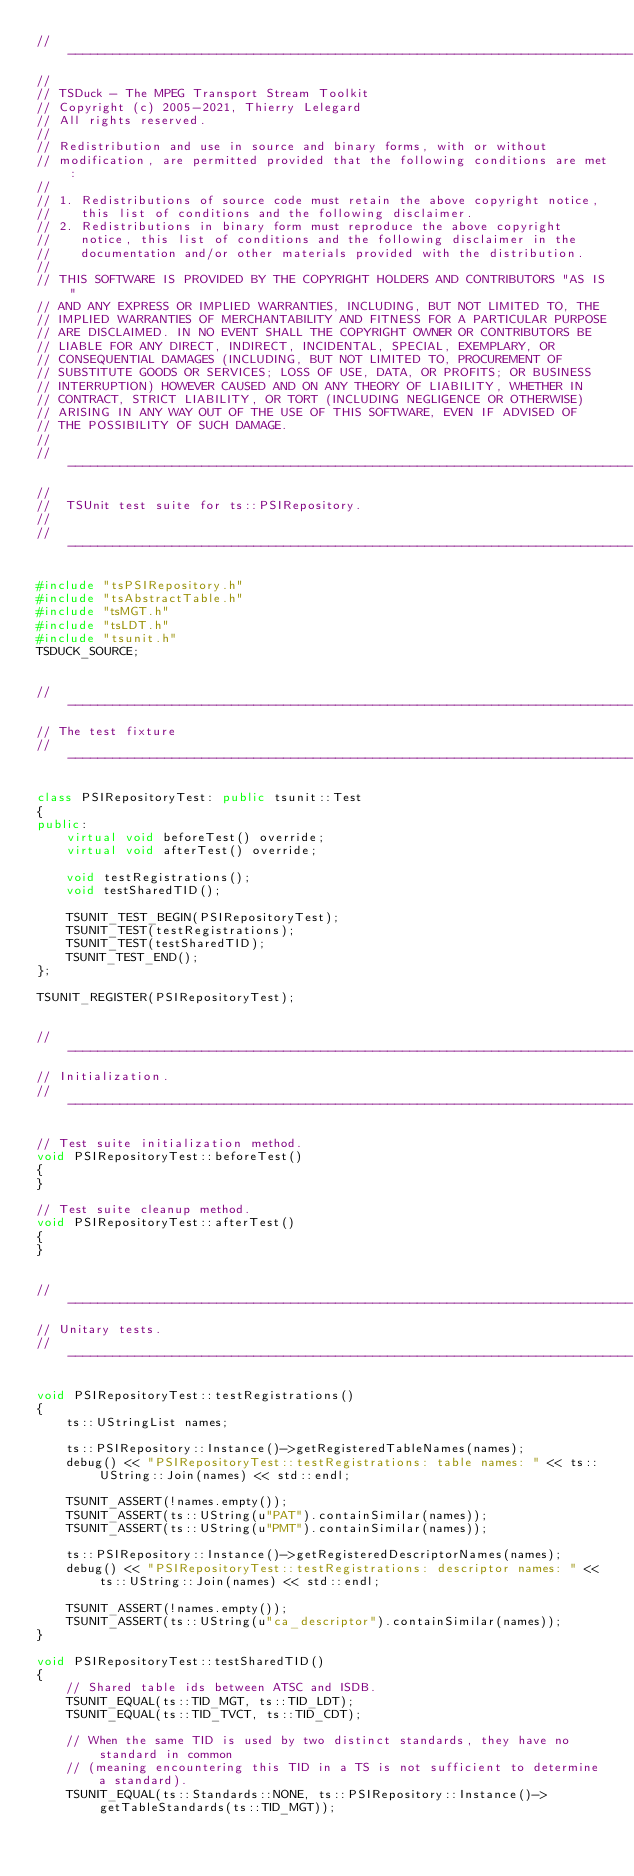<code> <loc_0><loc_0><loc_500><loc_500><_C++_>//----------------------------------------------------------------------------
//
// TSDuck - The MPEG Transport Stream Toolkit
// Copyright (c) 2005-2021, Thierry Lelegard
// All rights reserved.
//
// Redistribution and use in source and binary forms, with or without
// modification, are permitted provided that the following conditions are met:
//
// 1. Redistributions of source code must retain the above copyright notice,
//    this list of conditions and the following disclaimer.
// 2. Redistributions in binary form must reproduce the above copyright
//    notice, this list of conditions and the following disclaimer in the
//    documentation and/or other materials provided with the distribution.
//
// THIS SOFTWARE IS PROVIDED BY THE COPYRIGHT HOLDERS AND CONTRIBUTORS "AS IS"
// AND ANY EXPRESS OR IMPLIED WARRANTIES, INCLUDING, BUT NOT LIMITED TO, THE
// IMPLIED WARRANTIES OF MERCHANTABILITY AND FITNESS FOR A PARTICULAR PURPOSE
// ARE DISCLAIMED. IN NO EVENT SHALL THE COPYRIGHT OWNER OR CONTRIBUTORS BE
// LIABLE FOR ANY DIRECT, INDIRECT, INCIDENTAL, SPECIAL, EXEMPLARY, OR
// CONSEQUENTIAL DAMAGES (INCLUDING, BUT NOT LIMITED TO, PROCUREMENT OF
// SUBSTITUTE GOODS OR SERVICES; LOSS OF USE, DATA, OR PROFITS; OR BUSINESS
// INTERRUPTION) HOWEVER CAUSED AND ON ANY THEORY OF LIABILITY, WHETHER IN
// CONTRACT, STRICT LIABILITY, OR TORT (INCLUDING NEGLIGENCE OR OTHERWISE)
// ARISING IN ANY WAY OUT OF THE USE OF THIS SOFTWARE, EVEN IF ADVISED OF
// THE POSSIBILITY OF SUCH DAMAGE.
//
//----------------------------------------------------------------------------
//
//  TSUnit test suite for ts::PSIRepository.
//
//----------------------------------------------------------------------------

#include "tsPSIRepository.h"
#include "tsAbstractTable.h"
#include "tsMGT.h"
#include "tsLDT.h"
#include "tsunit.h"
TSDUCK_SOURCE;


//----------------------------------------------------------------------------
// The test fixture
//----------------------------------------------------------------------------

class PSIRepositoryTest: public tsunit::Test
{
public:
    virtual void beforeTest() override;
    virtual void afterTest() override;

    void testRegistrations();
    void testSharedTID();

    TSUNIT_TEST_BEGIN(PSIRepositoryTest);
    TSUNIT_TEST(testRegistrations);
    TSUNIT_TEST(testSharedTID);
    TSUNIT_TEST_END();
};

TSUNIT_REGISTER(PSIRepositoryTest);


//----------------------------------------------------------------------------
// Initialization.
//----------------------------------------------------------------------------

// Test suite initialization method.
void PSIRepositoryTest::beforeTest()
{
}

// Test suite cleanup method.
void PSIRepositoryTest::afterTest()
{
}


//----------------------------------------------------------------------------
// Unitary tests.
//----------------------------------------------------------------------------

void PSIRepositoryTest::testRegistrations()
{
    ts::UStringList names;

    ts::PSIRepository::Instance()->getRegisteredTableNames(names);
    debug() << "PSIRepositoryTest::testRegistrations: table names: " << ts::UString::Join(names) << std::endl;

    TSUNIT_ASSERT(!names.empty());
    TSUNIT_ASSERT(ts::UString(u"PAT").containSimilar(names));
    TSUNIT_ASSERT(ts::UString(u"PMT").containSimilar(names));

    ts::PSIRepository::Instance()->getRegisteredDescriptorNames(names);
    debug() << "PSIRepositoryTest::testRegistrations: descriptor names: " << ts::UString::Join(names) << std::endl;

    TSUNIT_ASSERT(!names.empty());
    TSUNIT_ASSERT(ts::UString(u"ca_descriptor").containSimilar(names));
}

void PSIRepositoryTest::testSharedTID()
{
    // Shared table ids between ATSC and ISDB.
    TSUNIT_EQUAL(ts::TID_MGT, ts::TID_LDT);
    TSUNIT_EQUAL(ts::TID_TVCT, ts::TID_CDT);

    // When the same TID is used by two distinct standards, they have no standard in common
    // (meaning encountering this TID in a TS is not sufficient to determine a standard).
    TSUNIT_EQUAL(ts::Standards::NONE, ts::PSIRepository::Instance()->getTableStandards(ts::TID_MGT));</code> 